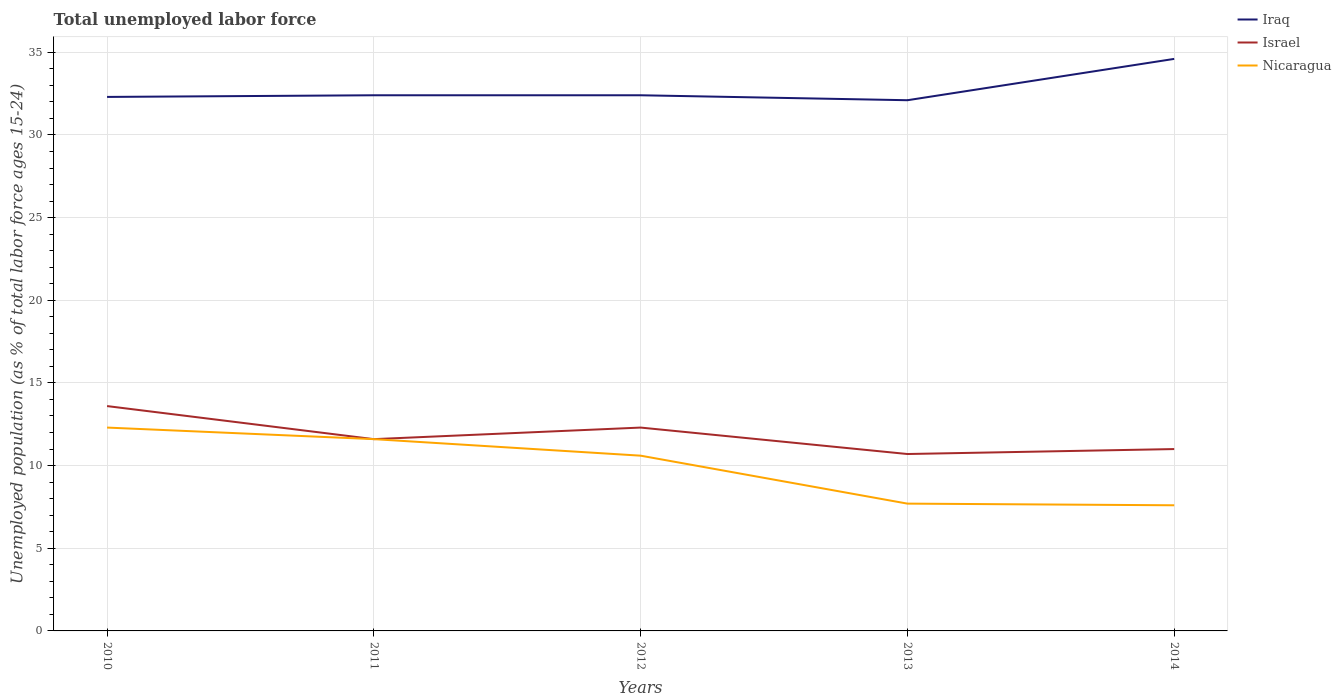How many different coloured lines are there?
Make the answer very short. 3. Does the line corresponding to Israel intersect with the line corresponding to Nicaragua?
Your answer should be very brief. Yes. Across all years, what is the maximum percentage of unemployed population in in Nicaragua?
Your answer should be compact. 7.6. What is the difference between the highest and the second highest percentage of unemployed population in in Israel?
Offer a terse response. 2.9. What is the difference between the highest and the lowest percentage of unemployed population in in Iraq?
Give a very brief answer. 1. Is the percentage of unemployed population in in Nicaragua strictly greater than the percentage of unemployed population in in Israel over the years?
Provide a succinct answer. No. Are the values on the major ticks of Y-axis written in scientific E-notation?
Make the answer very short. No. Does the graph contain any zero values?
Give a very brief answer. No. How are the legend labels stacked?
Your answer should be compact. Vertical. What is the title of the graph?
Your response must be concise. Total unemployed labor force. Does "Barbados" appear as one of the legend labels in the graph?
Your answer should be compact. No. What is the label or title of the X-axis?
Your answer should be very brief. Years. What is the label or title of the Y-axis?
Your response must be concise. Unemployed population (as % of total labor force ages 15-24). What is the Unemployed population (as % of total labor force ages 15-24) of Iraq in 2010?
Your response must be concise. 32.3. What is the Unemployed population (as % of total labor force ages 15-24) in Israel in 2010?
Offer a very short reply. 13.6. What is the Unemployed population (as % of total labor force ages 15-24) of Nicaragua in 2010?
Your answer should be very brief. 12.3. What is the Unemployed population (as % of total labor force ages 15-24) in Iraq in 2011?
Make the answer very short. 32.4. What is the Unemployed population (as % of total labor force ages 15-24) of Israel in 2011?
Keep it short and to the point. 11.6. What is the Unemployed population (as % of total labor force ages 15-24) of Nicaragua in 2011?
Make the answer very short. 11.6. What is the Unemployed population (as % of total labor force ages 15-24) of Iraq in 2012?
Your answer should be very brief. 32.4. What is the Unemployed population (as % of total labor force ages 15-24) of Israel in 2012?
Ensure brevity in your answer.  12.3. What is the Unemployed population (as % of total labor force ages 15-24) in Nicaragua in 2012?
Ensure brevity in your answer.  10.6. What is the Unemployed population (as % of total labor force ages 15-24) of Iraq in 2013?
Offer a terse response. 32.1. What is the Unemployed population (as % of total labor force ages 15-24) of Israel in 2013?
Ensure brevity in your answer.  10.7. What is the Unemployed population (as % of total labor force ages 15-24) in Nicaragua in 2013?
Give a very brief answer. 7.7. What is the Unemployed population (as % of total labor force ages 15-24) of Iraq in 2014?
Ensure brevity in your answer.  34.6. What is the Unemployed population (as % of total labor force ages 15-24) of Nicaragua in 2014?
Your answer should be compact. 7.6. Across all years, what is the maximum Unemployed population (as % of total labor force ages 15-24) of Iraq?
Make the answer very short. 34.6. Across all years, what is the maximum Unemployed population (as % of total labor force ages 15-24) in Israel?
Keep it short and to the point. 13.6. Across all years, what is the maximum Unemployed population (as % of total labor force ages 15-24) in Nicaragua?
Make the answer very short. 12.3. Across all years, what is the minimum Unemployed population (as % of total labor force ages 15-24) in Iraq?
Offer a very short reply. 32.1. Across all years, what is the minimum Unemployed population (as % of total labor force ages 15-24) of Israel?
Give a very brief answer. 10.7. Across all years, what is the minimum Unemployed population (as % of total labor force ages 15-24) of Nicaragua?
Offer a very short reply. 7.6. What is the total Unemployed population (as % of total labor force ages 15-24) of Iraq in the graph?
Offer a terse response. 163.8. What is the total Unemployed population (as % of total labor force ages 15-24) in Israel in the graph?
Your response must be concise. 59.2. What is the total Unemployed population (as % of total labor force ages 15-24) in Nicaragua in the graph?
Provide a succinct answer. 49.8. What is the difference between the Unemployed population (as % of total labor force ages 15-24) in Iraq in 2010 and that in 2011?
Make the answer very short. -0.1. What is the difference between the Unemployed population (as % of total labor force ages 15-24) in Israel in 2010 and that in 2011?
Your response must be concise. 2. What is the difference between the Unemployed population (as % of total labor force ages 15-24) of Iraq in 2010 and that in 2012?
Provide a succinct answer. -0.1. What is the difference between the Unemployed population (as % of total labor force ages 15-24) in Israel in 2010 and that in 2012?
Offer a very short reply. 1.3. What is the difference between the Unemployed population (as % of total labor force ages 15-24) in Iraq in 2010 and that in 2013?
Your answer should be very brief. 0.2. What is the difference between the Unemployed population (as % of total labor force ages 15-24) of Israel in 2010 and that in 2014?
Offer a terse response. 2.6. What is the difference between the Unemployed population (as % of total labor force ages 15-24) of Nicaragua in 2010 and that in 2014?
Keep it short and to the point. 4.7. What is the difference between the Unemployed population (as % of total labor force ages 15-24) in Israel in 2011 and that in 2012?
Your answer should be very brief. -0.7. What is the difference between the Unemployed population (as % of total labor force ages 15-24) in Iraq in 2011 and that in 2013?
Offer a terse response. 0.3. What is the difference between the Unemployed population (as % of total labor force ages 15-24) in Israel in 2011 and that in 2013?
Provide a short and direct response. 0.9. What is the difference between the Unemployed population (as % of total labor force ages 15-24) in Nicaragua in 2011 and that in 2013?
Provide a succinct answer. 3.9. What is the difference between the Unemployed population (as % of total labor force ages 15-24) of Iraq in 2011 and that in 2014?
Provide a succinct answer. -2.2. What is the difference between the Unemployed population (as % of total labor force ages 15-24) of Iraq in 2012 and that in 2013?
Provide a succinct answer. 0.3. What is the difference between the Unemployed population (as % of total labor force ages 15-24) of Israel in 2012 and that in 2014?
Your response must be concise. 1.3. What is the difference between the Unemployed population (as % of total labor force ages 15-24) in Nicaragua in 2012 and that in 2014?
Offer a terse response. 3. What is the difference between the Unemployed population (as % of total labor force ages 15-24) of Israel in 2013 and that in 2014?
Your response must be concise. -0.3. What is the difference between the Unemployed population (as % of total labor force ages 15-24) of Nicaragua in 2013 and that in 2014?
Provide a short and direct response. 0.1. What is the difference between the Unemployed population (as % of total labor force ages 15-24) in Iraq in 2010 and the Unemployed population (as % of total labor force ages 15-24) in Israel in 2011?
Provide a succinct answer. 20.7. What is the difference between the Unemployed population (as % of total labor force ages 15-24) in Iraq in 2010 and the Unemployed population (as % of total labor force ages 15-24) in Nicaragua in 2011?
Make the answer very short. 20.7. What is the difference between the Unemployed population (as % of total labor force ages 15-24) of Iraq in 2010 and the Unemployed population (as % of total labor force ages 15-24) of Nicaragua in 2012?
Keep it short and to the point. 21.7. What is the difference between the Unemployed population (as % of total labor force ages 15-24) in Iraq in 2010 and the Unemployed population (as % of total labor force ages 15-24) in Israel in 2013?
Keep it short and to the point. 21.6. What is the difference between the Unemployed population (as % of total labor force ages 15-24) of Iraq in 2010 and the Unemployed population (as % of total labor force ages 15-24) of Nicaragua in 2013?
Your response must be concise. 24.6. What is the difference between the Unemployed population (as % of total labor force ages 15-24) in Israel in 2010 and the Unemployed population (as % of total labor force ages 15-24) in Nicaragua in 2013?
Your response must be concise. 5.9. What is the difference between the Unemployed population (as % of total labor force ages 15-24) in Iraq in 2010 and the Unemployed population (as % of total labor force ages 15-24) in Israel in 2014?
Keep it short and to the point. 21.3. What is the difference between the Unemployed population (as % of total labor force ages 15-24) of Iraq in 2010 and the Unemployed population (as % of total labor force ages 15-24) of Nicaragua in 2014?
Offer a terse response. 24.7. What is the difference between the Unemployed population (as % of total labor force ages 15-24) in Iraq in 2011 and the Unemployed population (as % of total labor force ages 15-24) in Israel in 2012?
Provide a short and direct response. 20.1. What is the difference between the Unemployed population (as % of total labor force ages 15-24) of Iraq in 2011 and the Unemployed population (as % of total labor force ages 15-24) of Nicaragua in 2012?
Your answer should be compact. 21.8. What is the difference between the Unemployed population (as % of total labor force ages 15-24) in Iraq in 2011 and the Unemployed population (as % of total labor force ages 15-24) in Israel in 2013?
Your answer should be very brief. 21.7. What is the difference between the Unemployed population (as % of total labor force ages 15-24) of Iraq in 2011 and the Unemployed population (as % of total labor force ages 15-24) of Nicaragua in 2013?
Your answer should be very brief. 24.7. What is the difference between the Unemployed population (as % of total labor force ages 15-24) of Israel in 2011 and the Unemployed population (as % of total labor force ages 15-24) of Nicaragua in 2013?
Keep it short and to the point. 3.9. What is the difference between the Unemployed population (as % of total labor force ages 15-24) of Iraq in 2011 and the Unemployed population (as % of total labor force ages 15-24) of Israel in 2014?
Your answer should be very brief. 21.4. What is the difference between the Unemployed population (as % of total labor force ages 15-24) in Iraq in 2011 and the Unemployed population (as % of total labor force ages 15-24) in Nicaragua in 2014?
Give a very brief answer. 24.8. What is the difference between the Unemployed population (as % of total labor force ages 15-24) in Israel in 2011 and the Unemployed population (as % of total labor force ages 15-24) in Nicaragua in 2014?
Offer a very short reply. 4. What is the difference between the Unemployed population (as % of total labor force ages 15-24) in Iraq in 2012 and the Unemployed population (as % of total labor force ages 15-24) in Israel in 2013?
Give a very brief answer. 21.7. What is the difference between the Unemployed population (as % of total labor force ages 15-24) in Iraq in 2012 and the Unemployed population (as % of total labor force ages 15-24) in Nicaragua in 2013?
Provide a succinct answer. 24.7. What is the difference between the Unemployed population (as % of total labor force ages 15-24) in Iraq in 2012 and the Unemployed population (as % of total labor force ages 15-24) in Israel in 2014?
Keep it short and to the point. 21.4. What is the difference between the Unemployed population (as % of total labor force ages 15-24) in Iraq in 2012 and the Unemployed population (as % of total labor force ages 15-24) in Nicaragua in 2014?
Provide a short and direct response. 24.8. What is the difference between the Unemployed population (as % of total labor force ages 15-24) in Iraq in 2013 and the Unemployed population (as % of total labor force ages 15-24) in Israel in 2014?
Ensure brevity in your answer.  21.1. What is the difference between the Unemployed population (as % of total labor force ages 15-24) of Iraq in 2013 and the Unemployed population (as % of total labor force ages 15-24) of Nicaragua in 2014?
Your answer should be very brief. 24.5. What is the average Unemployed population (as % of total labor force ages 15-24) of Iraq per year?
Offer a terse response. 32.76. What is the average Unemployed population (as % of total labor force ages 15-24) of Israel per year?
Make the answer very short. 11.84. What is the average Unemployed population (as % of total labor force ages 15-24) in Nicaragua per year?
Your answer should be very brief. 9.96. In the year 2010, what is the difference between the Unemployed population (as % of total labor force ages 15-24) of Iraq and Unemployed population (as % of total labor force ages 15-24) of Israel?
Your response must be concise. 18.7. In the year 2010, what is the difference between the Unemployed population (as % of total labor force ages 15-24) in Israel and Unemployed population (as % of total labor force ages 15-24) in Nicaragua?
Provide a succinct answer. 1.3. In the year 2011, what is the difference between the Unemployed population (as % of total labor force ages 15-24) in Iraq and Unemployed population (as % of total labor force ages 15-24) in Israel?
Provide a short and direct response. 20.8. In the year 2011, what is the difference between the Unemployed population (as % of total labor force ages 15-24) of Iraq and Unemployed population (as % of total labor force ages 15-24) of Nicaragua?
Offer a terse response. 20.8. In the year 2011, what is the difference between the Unemployed population (as % of total labor force ages 15-24) in Israel and Unemployed population (as % of total labor force ages 15-24) in Nicaragua?
Give a very brief answer. 0. In the year 2012, what is the difference between the Unemployed population (as % of total labor force ages 15-24) of Iraq and Unemployed population (as % of total labor force ages 15-24) of Israel?
Provide a short and direct response. 20.1. In the year 2012, what is the difference between the Unemployed population (as % of total labor force ages 15-24) in Iraq and Unemployed population (as % of total labor force ages 15-24) in Nicaragua?
Give a very brief answer. 21.8. In the year 2013, what is the difference between the Unemployed population (as % of total labor force ages 15-24) of Iraq and Unemployed population (as % of total labor force ages 15-24) of Israel?
Ensure brevity in your answer.  21.4. In the year 2013, what is the difference between the Unemployed population (as % of total labor force ages 15-24) in Iraq and Unemployed population (as % of total labor force ages 15-24) in Nicaragua?
Offer a very short reply. 24.4. In the year 2014, what is the difference between the Unemployed population (as % of total labor force ages 15-24) in Iraq and Unemployed population (as % of total labor force ages 15-24) in Israel?
Your response must be concise. 23.6. What is the ratio of the Unemployed population (as % of total labor force ages 15-24) of Israel in 2010 to that in 2011?
Keep it short and to the point. 1.17. What is the ratio of the Unemployed population (as % of total labor force ages 15-24) of Nicaragua in 2010 to that in 2011?
Ensure brevity in your answer.  1.06. What is the ratio of the Unemployed population (as % of total labor force ages 15-24) in Iraq in 2010 to that in 2012?
Your answer should be very brief. 1. What is the ratio of the Unemployed population (as % of total labor force ages 15-24) in Israel in 2010 to that in 2012?
Provide a short and direct response. 1.11. What is the ratio of the Unemployed population (as % of total labor force ages 15-24) of Nicaragua in 2010 to that in 2012?
Make the answer very short. 1.16. What is the ratio of the Unemployed population (as % of total labor force ages 15-24) of Israel in 2010 to that in 2013?
Offer a very short reply. 1.27. What is the ratio of the Unemployed population (as % of total labor force ages 15-24) in Nicaragua in 2010 to that in 2013?
Make the answer very short. 1.6. What is the ratio of the Unemployed population (as % of total labor force ages 15-24) of Iraq in 2010 to that in 2014?
Keep it short and to the point. 0.93. What is the ratio of the Unemployed population (as % of total labor force ages 15-24) in Israel in 2010 to that in 2014?
Your answer should be compact. 1.24. What is the ratio of the Unemployed population (as % of total labor force ages 15-24) of Nicaragua in 2010 to that in 2014?
Give a very brief answer. 1.62. What is the ratio of the Unemployed population (as % of total labor force ages 15-24) in Israel in 2011 to that in 2012?
Your response must be concise. 0.94. What is the ratio of the Unemployed population (as % of total labor force ages 15-24) of Nicaragua in 2011 to that in 2012?
Keep it short and to the point. 1.09. What is the ratio of the Unemployed population (as % of total labor force ages 15-24) of Iraq in 2011 to that in 2013?
Your answer should be compact. 1.01. What is the ratio of the Unemployed population (as % of total labor force ages 15-24) of Israel in 2011 to that in 2013?
Give a very brief answer. 1.08. What is the ratio of the Unemployed population (as % of total labor force ages 15-24) of Nicaragua in 2011 to that in 2013?
Ensure brevity in your answer.  1.51. What is the ratio of the Unemployed population (as % of total labor force ages 15-24) of Iraq in 2011 to that in 2014?
Keep it short and to the point. 0.94. What is the ratio of the Unemployed population (as % of total labor force ages 15-24) of Israel in 2011 to that in 2014?
Make the answer very short. 1.05. What is the ratio of the Unemployed population (as % of total labor force ages 15-24) of Nicaragua in 2011 to that in 2014?
Your response must be concise. 1.53. What is the ratio of the Unemployed population (as % of total labor force ages 15-24) of Iraq in 2012 to that in 2013?
Keep it short and to the point. 1.01. What is the ratio of the Unemployed population (as % of total labor force ages 15-24) in Israel in 2012 to that in 2013?
Ensure brevity in your answer.  1.15. What is the ratio of the Unemployed population (as % of total labor force ages 15-24) of Nicaragua in 2012 to that in 2013?
Provide a succinct answer. 1.38. What is the ratio of the Unemployed population (as % of total labor force ages 15-24) in Iraq in 2012 to that in 2014?
Give a very brief answer. 0.94. What is the ratio of the Unemployed population (as % of total labor force ages 15-24) in Israel in 2012 to that in 2014?
Your answer should be compact. 1.12. What is the ratio of the Unemployed population (as % of total labor force ages 15-24) in Nicaragua in 2012 to that in 2014?
Provide a short and direct response. 1.39. What is the ratio of the Unemployed population (as % of total labor force ages 15-24) in Iraq in 2013 to that in 2014?
Make the answer very short. 0.93. What is the ratio of the Unemployed population (as % of total labor force ages 15-24) of Israel in 2013 to that in 2014?
Provide a short and direct response. 0.97. What is the ratio of the Unemployed population (as % of total labor force ages 15-24) in Nicaragua in 2013 to that in 2014?
Give a very brief answer. 1.01. What is the difference between the highest and the second highest Unemployed population (as % of total labor force ages 15-24) of Israel?
Your response must be concise. 1.3. What is the difference between the highest and the second highest Unemployed population (as % of total labor force ages 15-24) of Nicaragua?
Offer a very short reply. 0.7. What is the difference between the highest and the lowest Unemployed population (as % of total labor force ages 15-24) of Israel?
Make the answer very short. 2.9. 